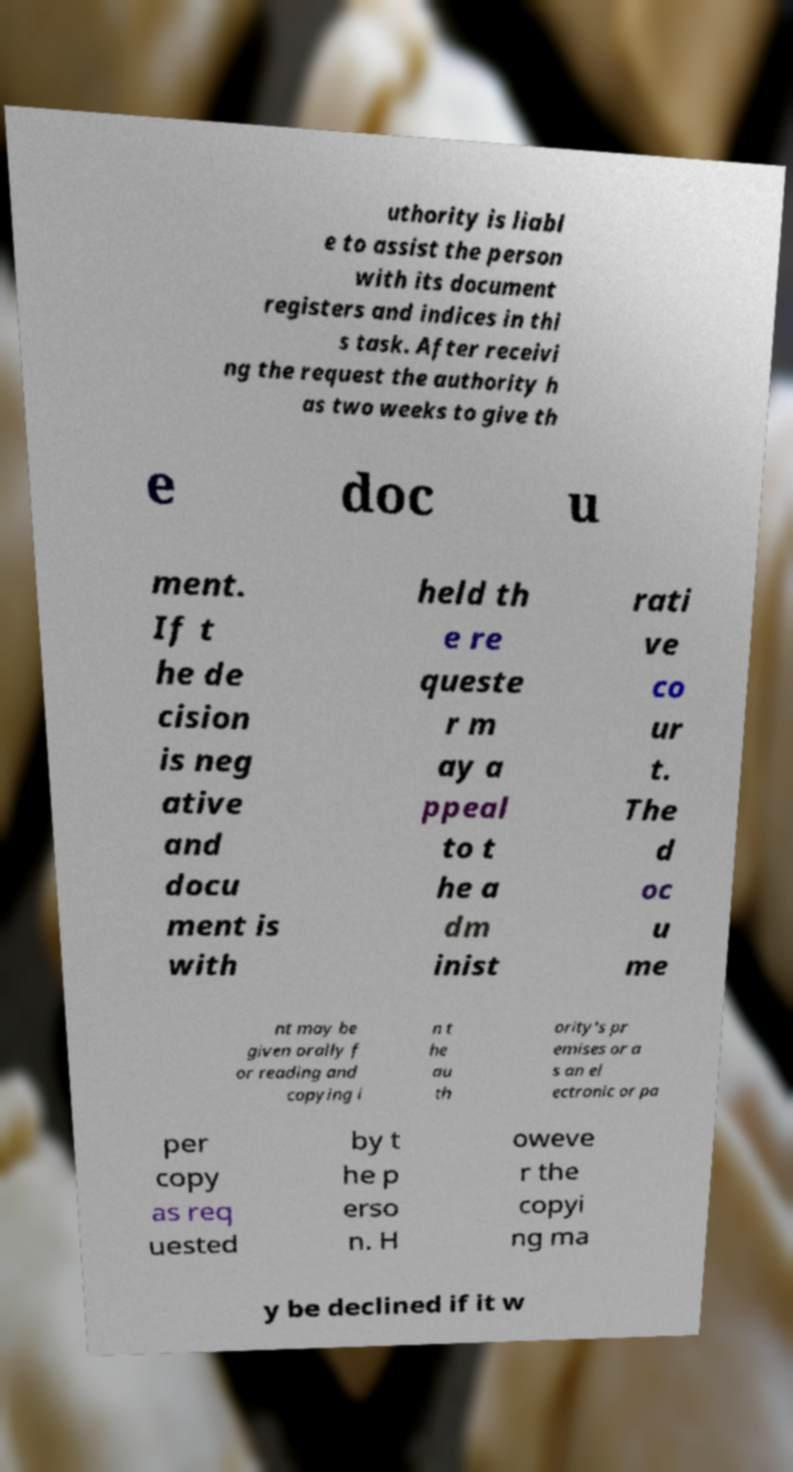What messages or text are displayed in this image? I need them in a readable, typed format. uthority is liabl e to assist the person with its document registers and indices in thi s task. After receivi ng the request the authority h as two weeks to give th e doc u ment. If t he de cision is neg ative and docu ment is with held th e re queste r m ay a ppeal to t he a dm inist rati ve co ur t. The d oc u me nt may be given orally f or reading and copying i n t he au th ority's pr emises or a s an el ectronic or pa per copy as req uested by t he p erso n. H oweve r the copyi ng ma y be declined if it w 